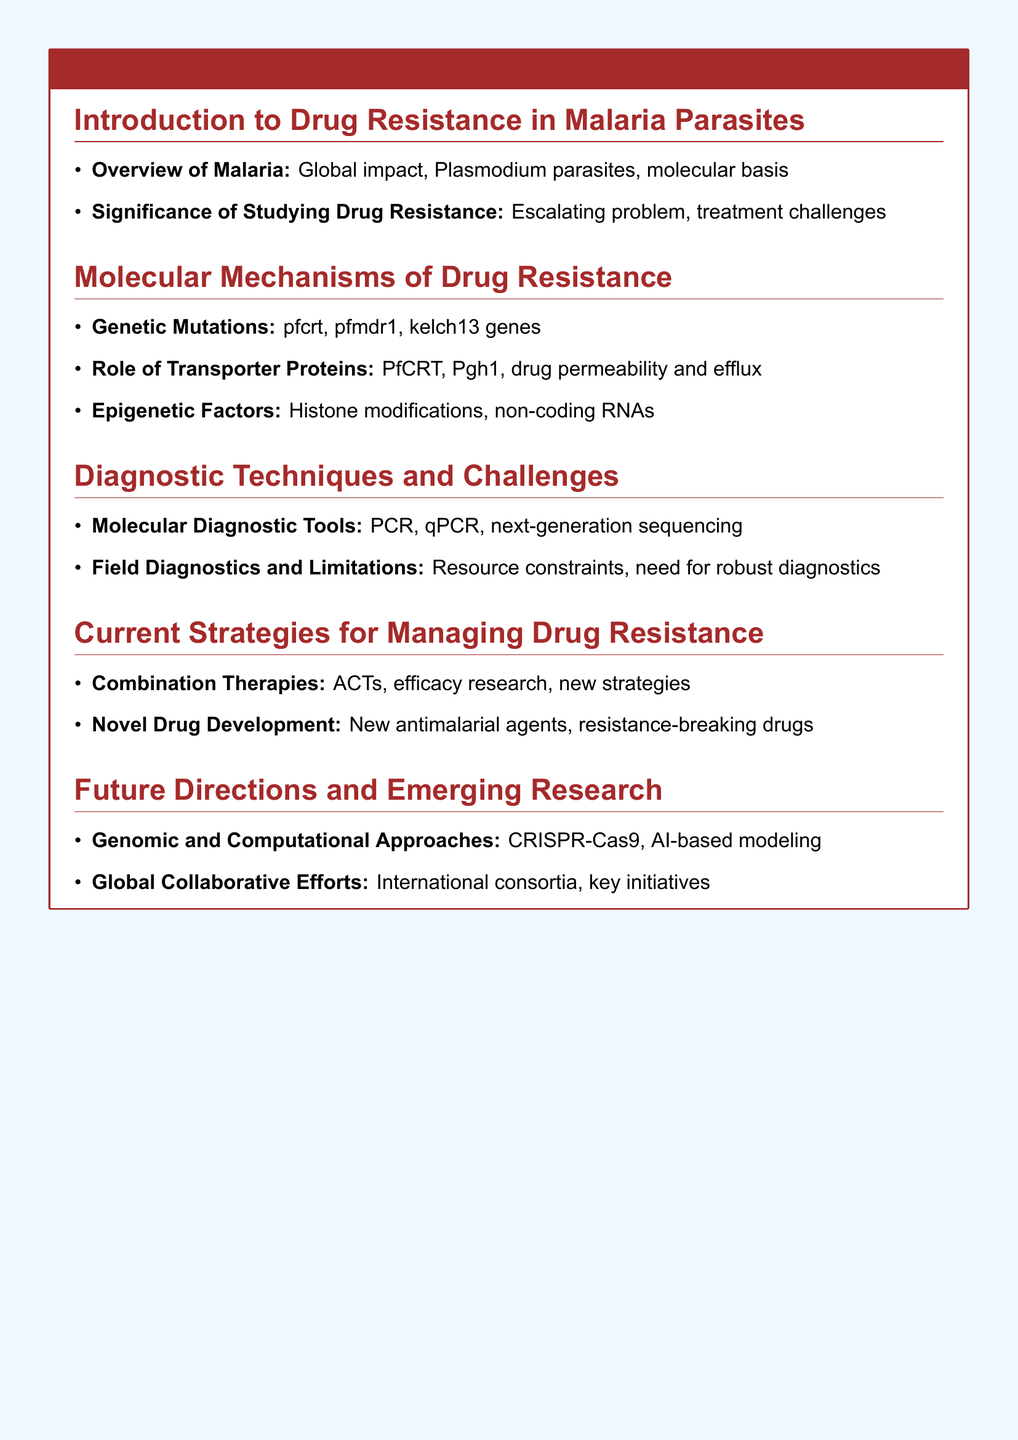What are the key genes associated with genetic mutations in drug resistance? The key genes are pfcrt, pfmdr1, and kelch13.
Answer: pfcrt, pfmdr1, kelch13 What role do transporter proteins play in drug resistance? Transporter proteins such as PfCRT and Pgh1 are involved in drug permeability and efflux.
Answer: Drug permeability and efflux What molecular diagnostic tool is mentioned as a method for detecting drug resistance? PCR, qPCR, and next-generation sequencing are mentioned as molecular diagnostic tools.
Answer: PCR What is the focus of combination therapies in managing drug resistance? Combination therapies focus on ACTs and efficacy research.
Answer: ACTs Which advanced approach is highlighted for future research in drug resistance? Genomic and Computational Approaches including CRISPR-Cas9 and AI-based modeling are highlighted.
Answer: CRISPR-Cas9 What is a significant challenge in field diagnostics? Resource constraints are a significant challenge.
Answer: Resource constraints What are emerging global efforts mentioned to combat drug resistance? Global collaborative efforts involve international consortia and key initiatives.
Answer: International consortia What is the main significance of studying drug resistance? The significance lies in addressing the escalating problem and treatment challenges.
Answer: Escalating problem What type of agents is being sought after in novel drug development efforts? The efforts are geared towards new antimalarial agents and resistance-breaking drugs.
Answer: New antimalarial agents 